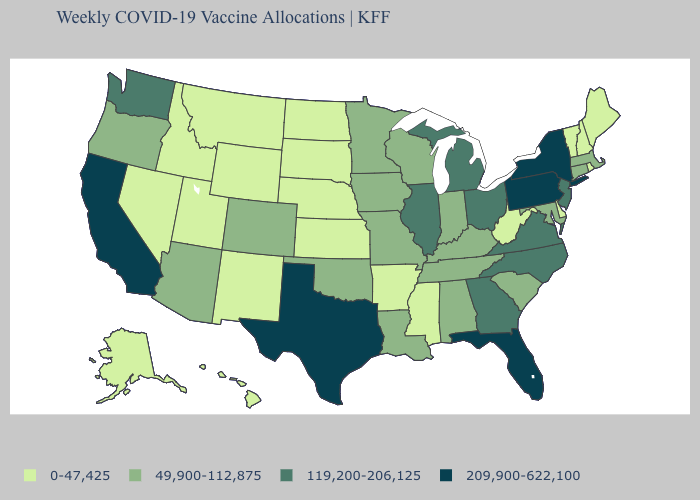Does Maryland have the highest value in the USA?
Short answer required. No. What is the value of Texas?
Be succinct. 209,900-622,100. What is the value of Pennsylvania?
Answer briefly. 209,900-622,100. Which states have the highest value in the USA?
Concise answer only. California, Florida, New York, Pennsylvania, Texas. Which states have the highest value in the USA?
Write a very short answer. California, Florida, New York, Pennsylvania, Texas. Among the states that border Georgia , which have the lowest value?
Short answer required. Alabama, South Carolina, Tennessee. Is the legend a continuous bar?
Keep it brief. No. What is the value of Minnesota?
Give a very brief answer. 49,900-112,875. Does Nevada have the lowest value in the USA?
Short answer required. Yes. Is the legend a continuous bar?
Answer briefly. No. Among the states that border Kentucky , does Missouri have the highest value?
Be succinct. No. Among the states that border Pennsylvania , which have the lowest value?
Keep it brief. Delaware, West Virginia. What is the value of Alaska?
Concise answer only. 0-47,425. Which states have the lowest value in the West?
Write a very short answer. Alaska, Hawaii, Idaho, Montana, Nevada, New Mexico, Utah, Wyoming. Name the states that have a value in the range 119,200-206,125?
Give a very brief answer. Georgia, Illinois, Michigan, New Jersey, North Carolina, Ohio, Virginia, Washington. 